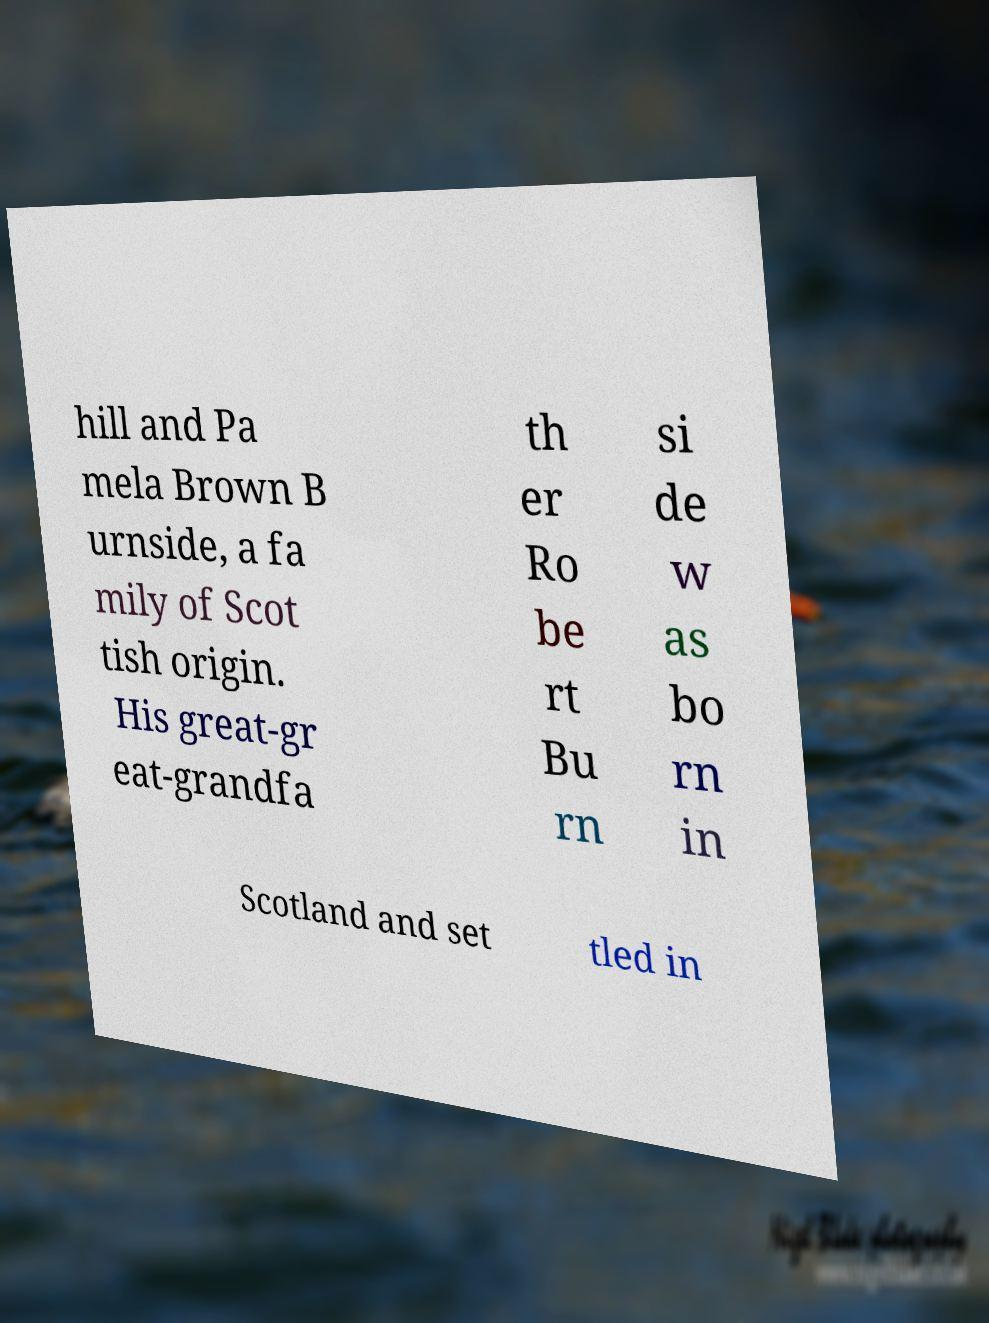Please identify and transcribe the text found in this image. hill and Pa mela Brown B urnside, a fa mily of Scot tish origin. His great-gr eat-grandfa th er Ro be rt Bu rn si de w as bo rn in Scotland and set tled in 